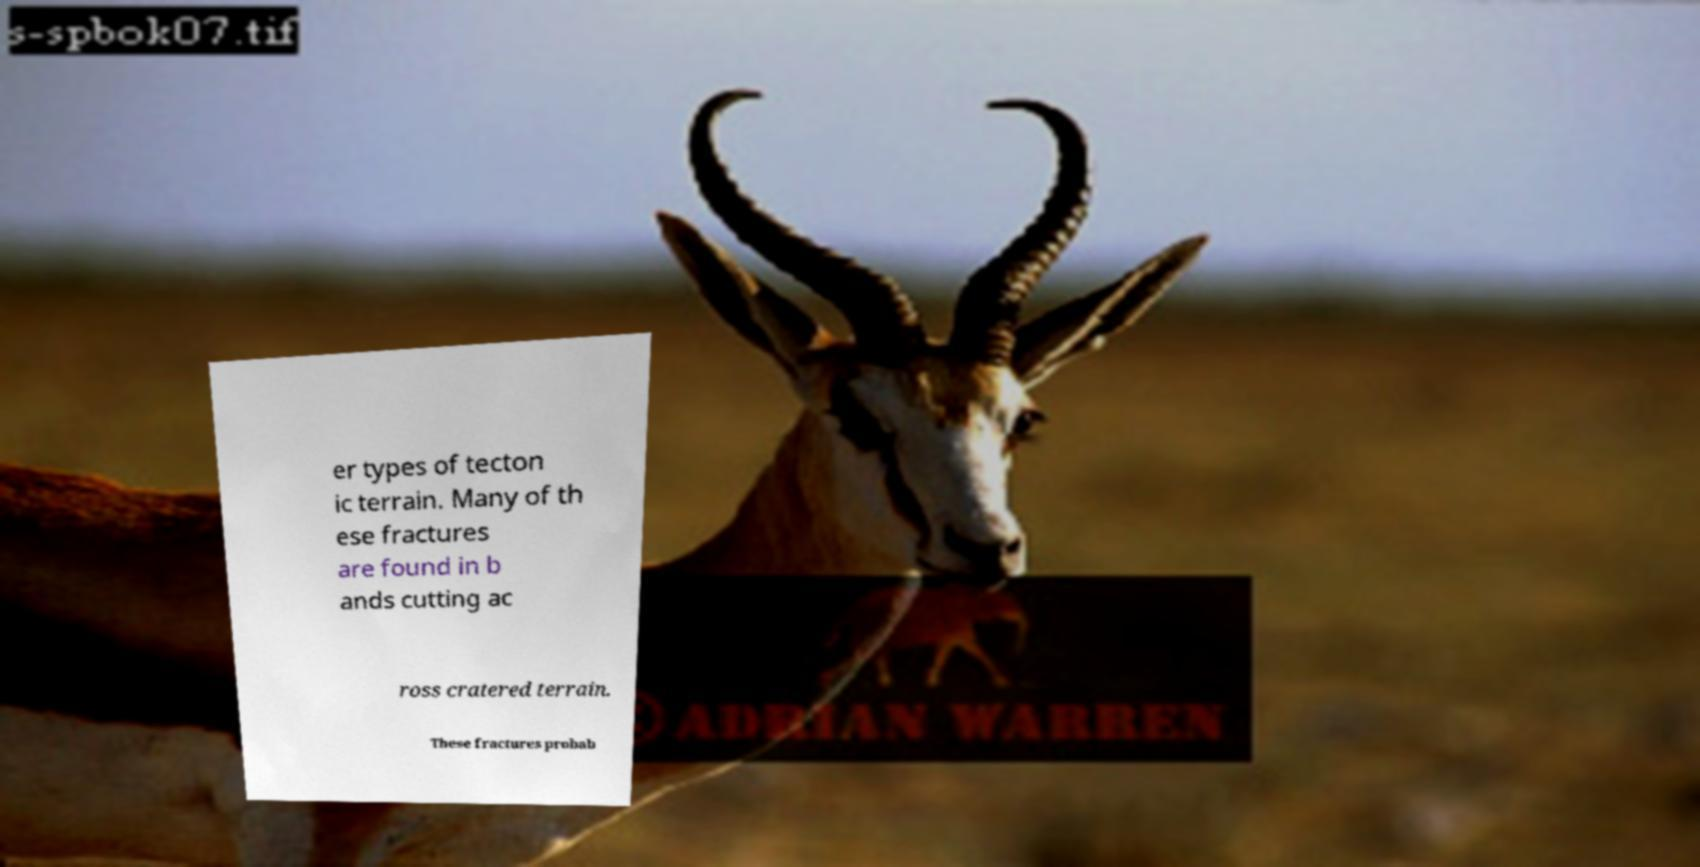What messages or text are displayed in this image? I need them in a readable, typed format. er types of tecton ic terrain. Many of th ese fractures are found in b ands cutting ac ross cratered terrain. These fractures probab 